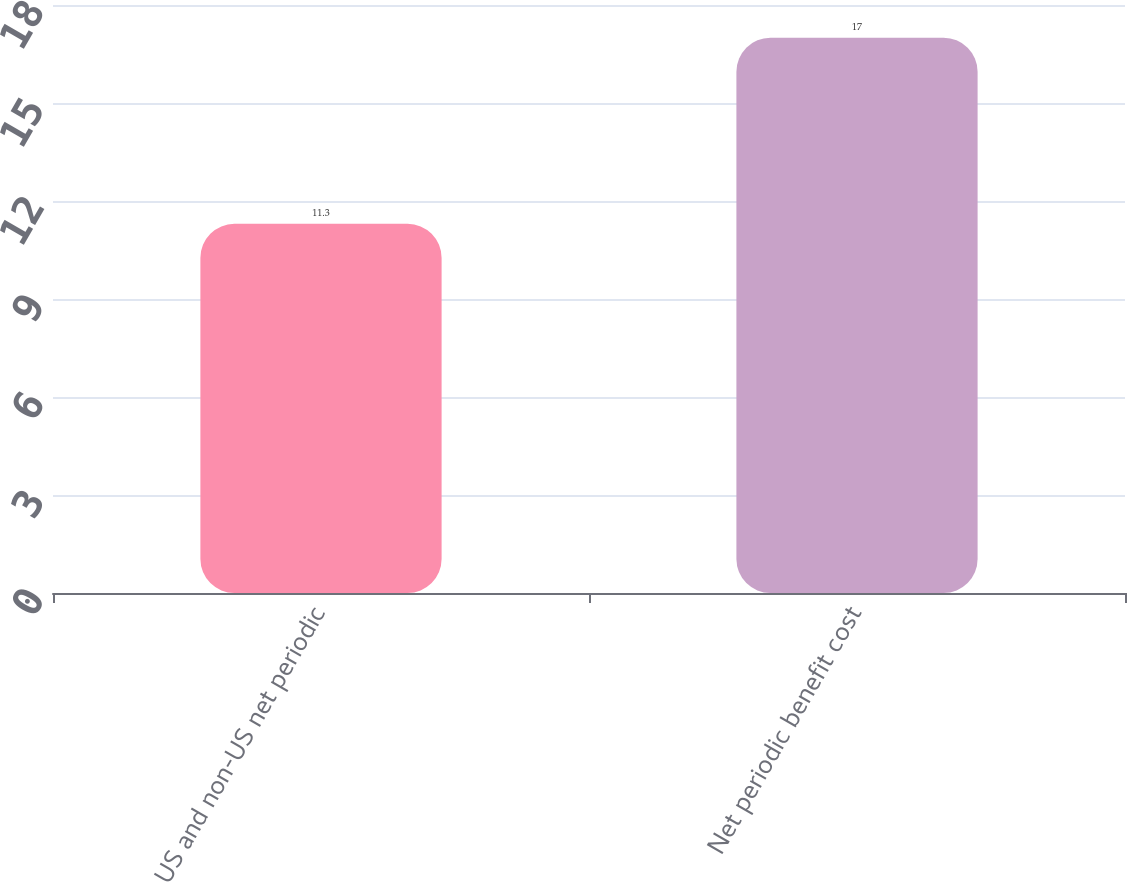Convert chart to OTSL. <chart><loc_0><loc_0><loc_500><loc_500><bar_chart><fcel>US and non-US net periodic<fcel>Net periodic benefit cost<nl><fcel>11.3<fcel>17<nl></chart> 